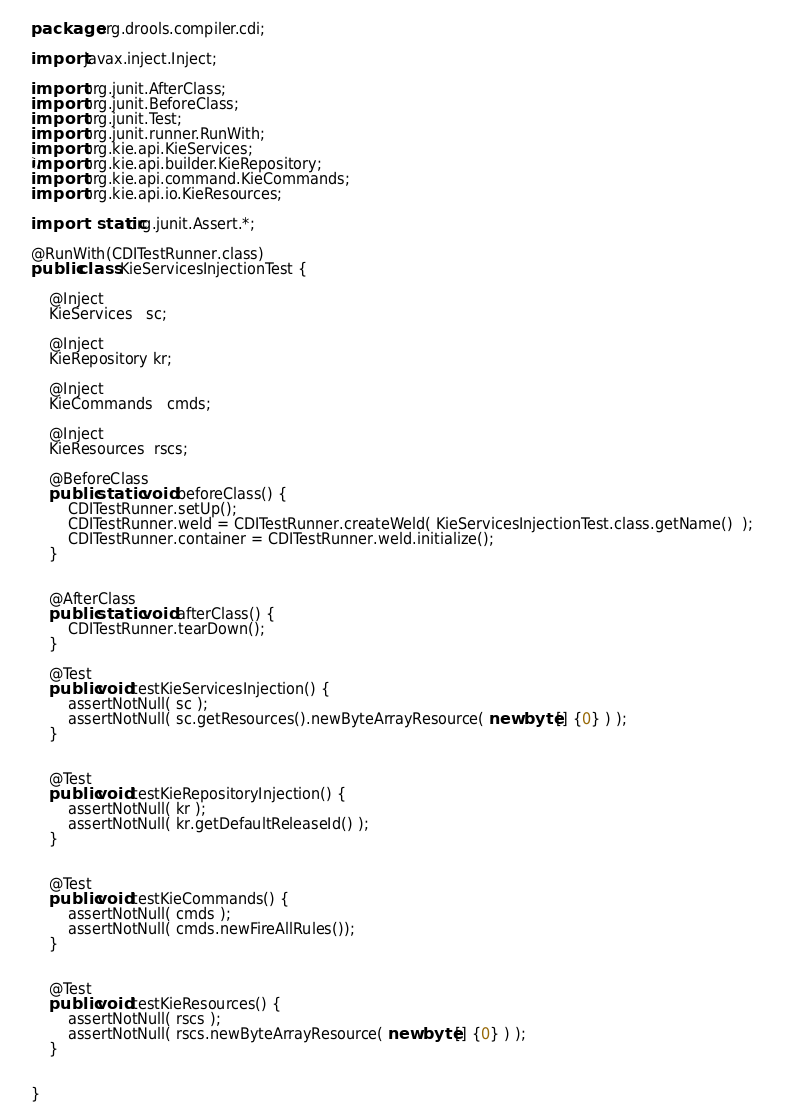<code> <loc_0><loc_0><loc_500><loc_500><_Java_>package org.drools.compiler.cdi;

import javax.inject.Inject;

import org.junit.AfterClass;
import org.junit.BeforeClass;
import org.junit.Test;
import org.junit.runner.RunWith;
import org.kie.api.KieServices;
import org.kie.api.builder.KieRepository;
import org.kie.api.command.KieCommands;
import org.kie.api.io.KieResources;

import static org.junit.Assert.*;

@RunWith(CDITestRunner.class)
public class KieServicesInjectionTest {
    
    @Inject
    KieServices   sc;

    @Inject
    KieRepository kr;

    @Inject
    KieCommands   cmds;
    
    @Inject
    KieResources  rscs;
    
    @BeforeClass
    public static void beforeClass() {   
        CDITestRunner.setUp();
        CDITestRunner.weld = CDITestRunner.createWeld( KieServicesInjectionTest.class.getName()  );        
        CDITestRunner.container = CDITestRunner.weld.initialize();
    }


    @AfterClass
    public static void afterClass() {
        CDITestRunner.tearDown();
    }   
    
    @Test
    public void testKieServicesInjection() {
        assertNotNull( sc );
        assertNotNull( sc.getResources().newByteArrayResource( new byte[] {0} ) );
    }

    
    @Test
    public void testKieRepositoryInjection() {
        assertNotNull( kr );
        assertNotNull( kr.getDefaultReleaseId() );
    }
    
    
    @Test
    public void testKieCommands() {
        assertNotNull( cmds );
        assertNotNull( cmds.newFireAllRules());
    }
    
    
    @Test
    public void testKieResources() {
        assertNotNull( rscs );
        assertNotNull( rscs.newByteArrayResource( new byte[] {0} ) );
    }   
    
    
}
</code> 